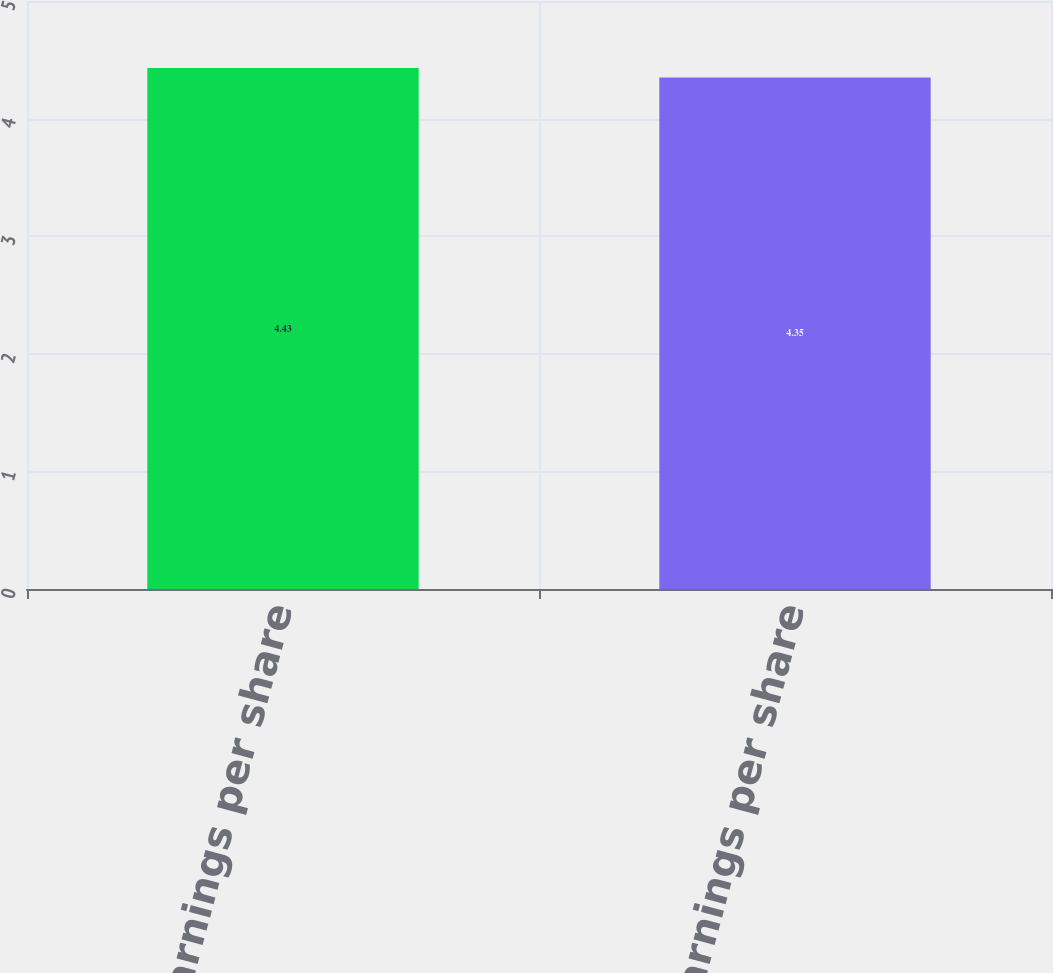<chart> <loc_0><loc_0><loc_500><loc_500><bar_chart><fcel>Basic earnings per share<fcel>Diluted earnings per share<nl><fcel>4.43<fcel>4.35<nl></chart> 